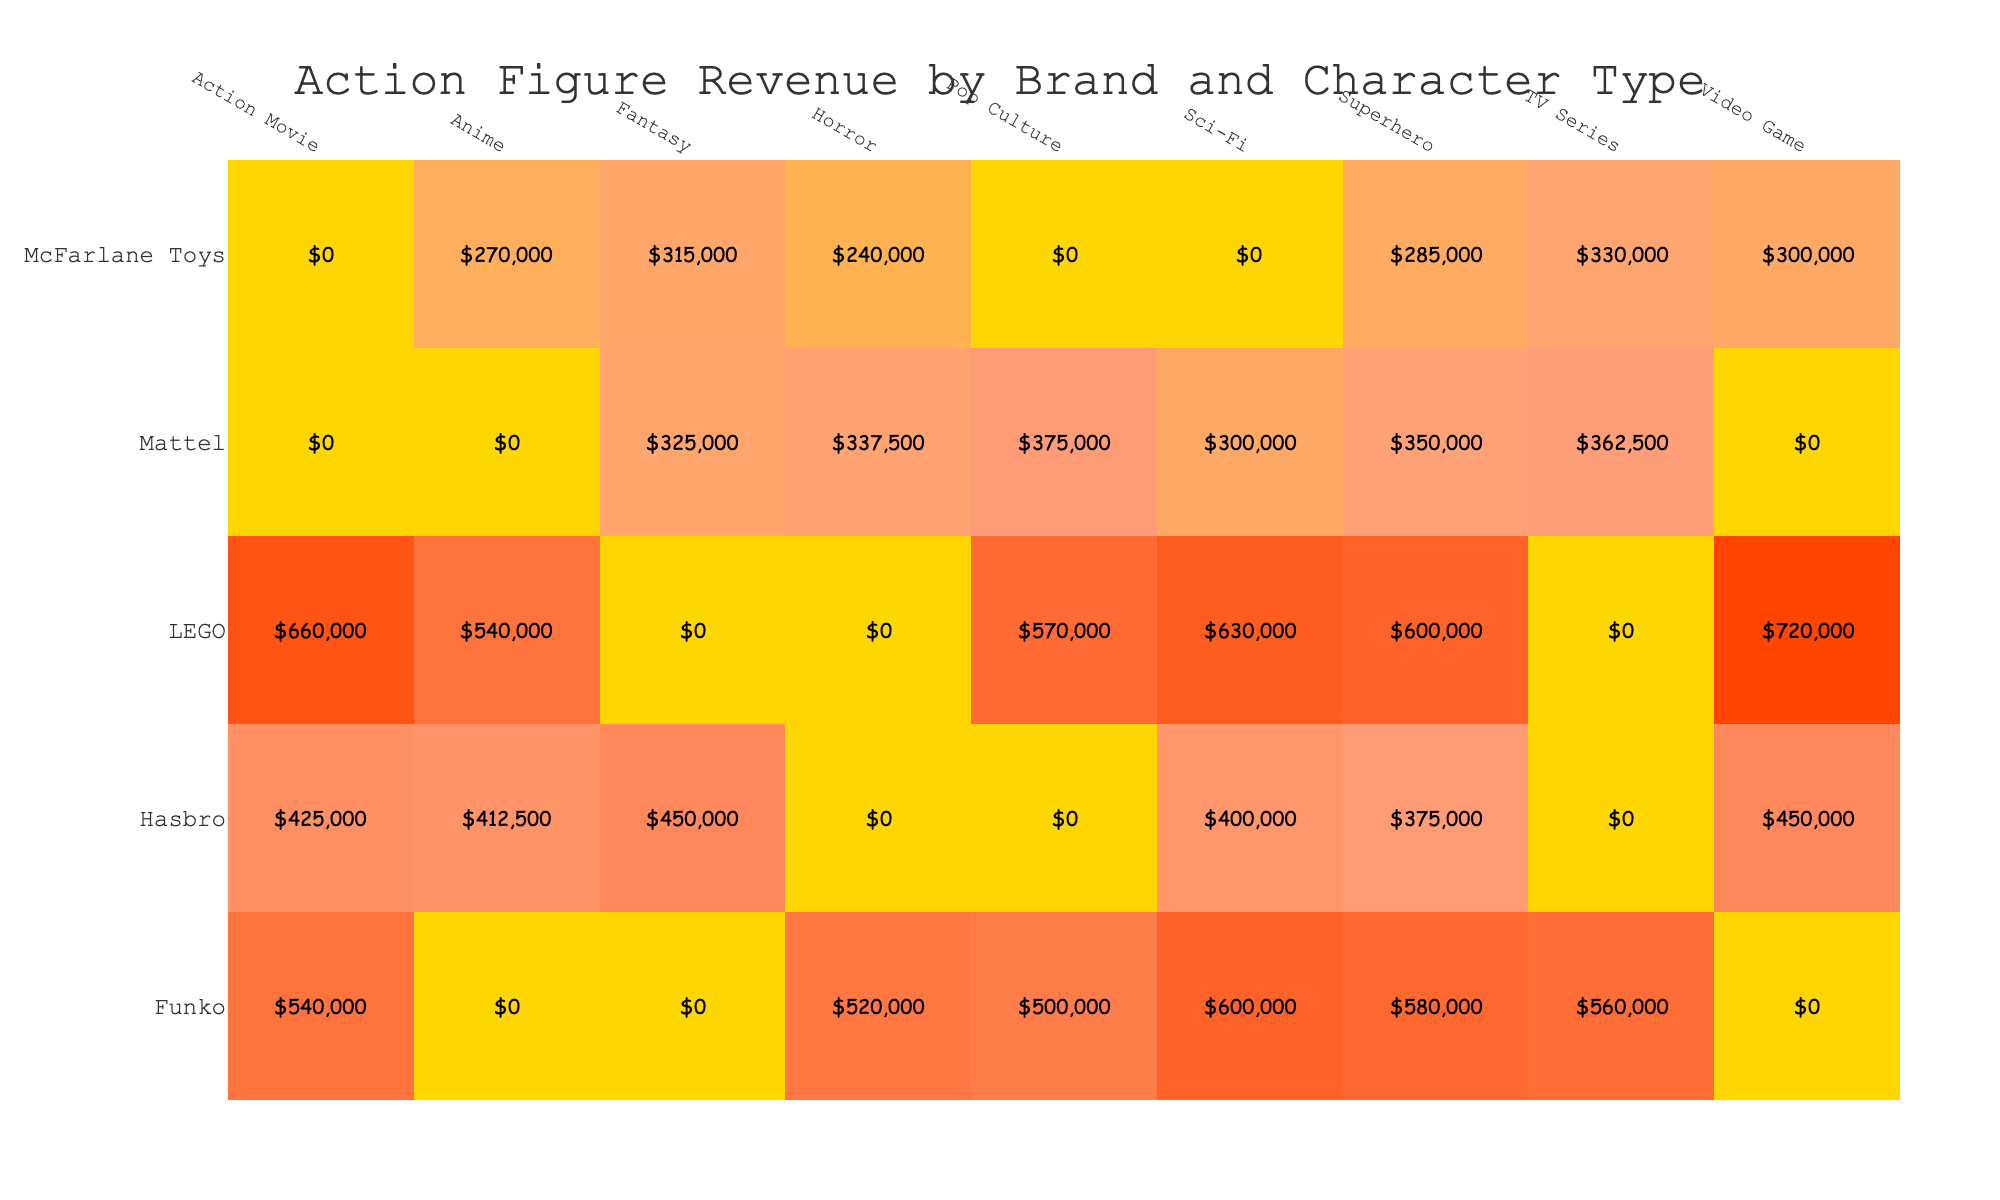What brand sold the most units of superhero action figures in 2020? The table indicates that Hasbro sold 15,000 units of superhero action figures in Q1 2020. Additionally, in Q3 2020, Mattel sold 14,000 units. Comparing these figures, Hasbro had the highest unit sales for superhero action figures in 2020.
Answer: Hasbro What was the total revenue from Action Movie character types across all brands in 2020? The revenue from Action Movie character types in 2020 includes Hasbro's revenue of $425,000 from Q2 and Funko's revenue of $540,000 from Q1. Summing them up gives $425,000 + $540,000 = $965,000.
Answer: $965,000 Did Funko sell more units in TV Series character types than McFarlane Toys in the same category in 2020? Funko sold 28,000 units in Q2 2020 under TV Series, while McFarlane Toys sold 11,000 units in Q4 2020 under the same category. Therefore, the statement is true as Funko's sales exceed McFarlane Toys' sales.
Answer: Yes What is the average revenue per unit sold for LEGO's Action Movie character type in 2020? LEGO's Action Movie character type sold 22,000 units in Q3 2020 for a total revenue of $660,000. Dividing the revenue by units sold gives $660,000 / 22,000 = $30 per unit.
Answer: $30 Which brand had the lowest revenue from Horror character types in 2020? The revenue data for Horror character types shows McFarlane Toys with $240,000 in Q1 2020 and Mattel with $337,500 in Q1 2021. Thus, McFarlane Toys had the lowest revenue from Horror character types in 2020.
Answer: McFarlane Toys 